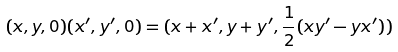Convert formula to latex. <formula><loc_0><loc_0><loc_500><loc_500>( x , y , 0 ) ( x ^ { \prime } , y ^ { \prime } , 0 ) = ( x + x ^ { \prime } , y + y ^ { \prime } , \frac { 1 } { 2 } ( x y ^ { \prime } - y x ^ { \prime } ) )</formula> 